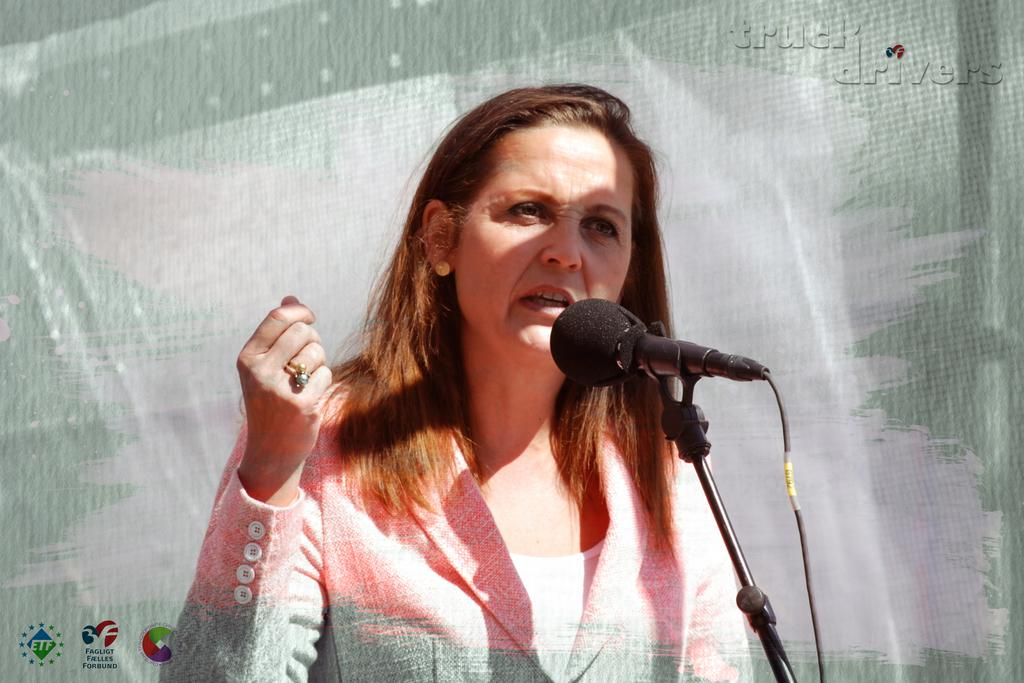Who is the main subject in the image? There is a woman in the image. What is the woman doing in the image? The woman is in front of a mic. Are there any visible watermarks in the image? Yes, there is a watermark in the top right corner and another in the bottom left corner of the image. What type of farm animals can be seen in the image? There are no farm animals present in the image. What kind of jam is being prepared in the image? There is no jam preparation or any reference to jam in the image. 